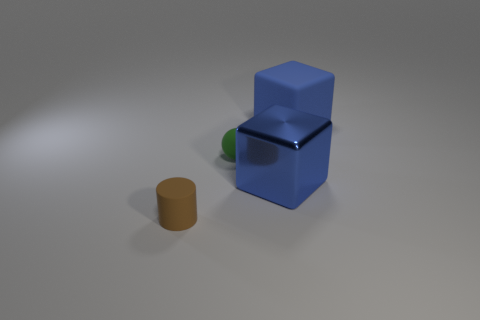How many tiny rubber things are behind the large blue cube that is in front of the blue rubber cube?
Provide a succinct answer. 1. Is the number of small rubber cylinders in front of the big matte object less than the number of brown rubber cylinders?
Provide a succinct answer. No. There is a big block behind the blue block to the left of the big rubber cube; is there a blue metallic block that is behind it?
Ensure brevity in your answer.  No. Do the tiny cylinder and the large block in front of the blue rubber cube have the same material?
Your response must be concise. No. The big thing that is in front of the tiny rubber object behind the brown cylinder is what color?
Give a very brief answer. Blue. Are there any small matte objects of the same color as the big matte cube?
Make the answer very short. No. What is the size of the blue block that is to the right of the blue block left of the large rubber block to the right of the tiny green rubber sphere?
Your response must be concise. Large. There is a large blue metal thing; is it the same shape as the object left of the sphere?
Keep it short and to the point. No. How many other things are the same size as the green sphere?
Keep it short and to the point. 1. There is a blue cube left of the blue rubber cube; what is its size?
Provide a succinct answer. Large. 